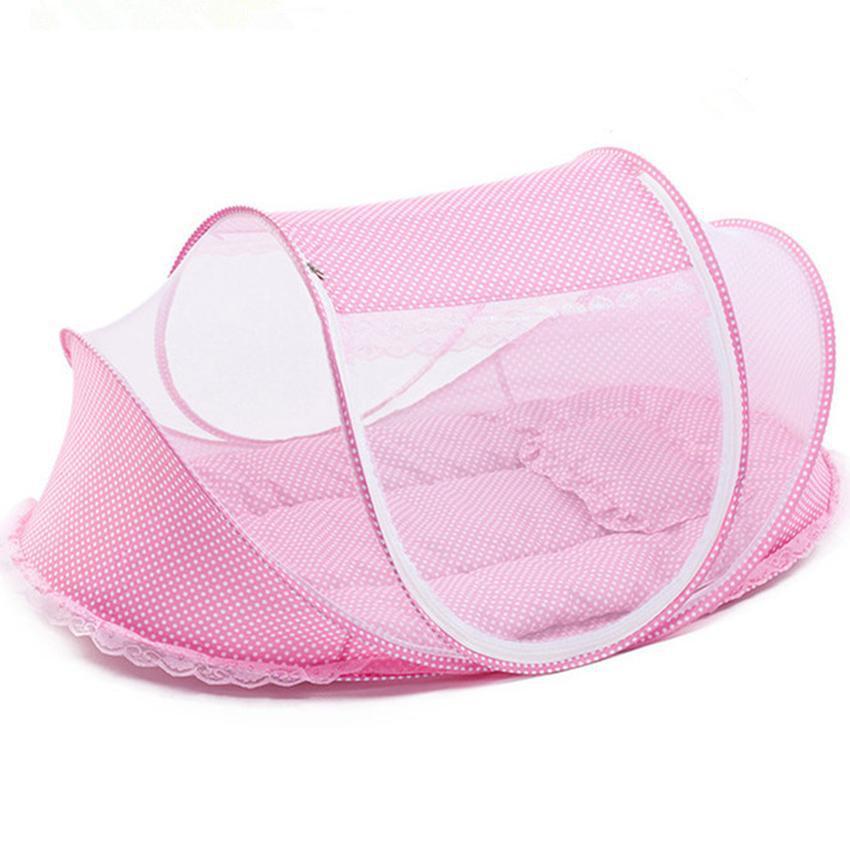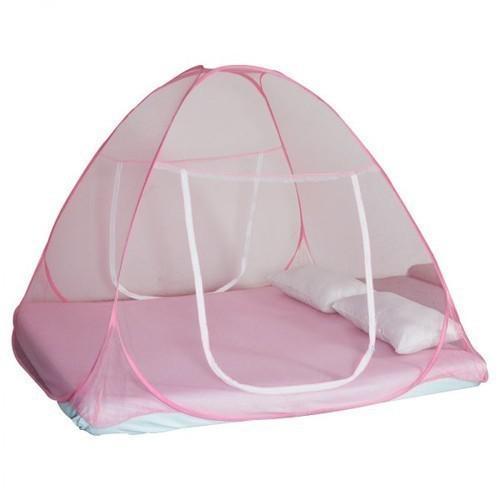The first image is the image on the left, the second image is the image on the right. Examine the images to the left and right. Is the description "In one image, the baby bed is solid pink and has a shell cover over one end." accurate? Answer yes or no. No. 